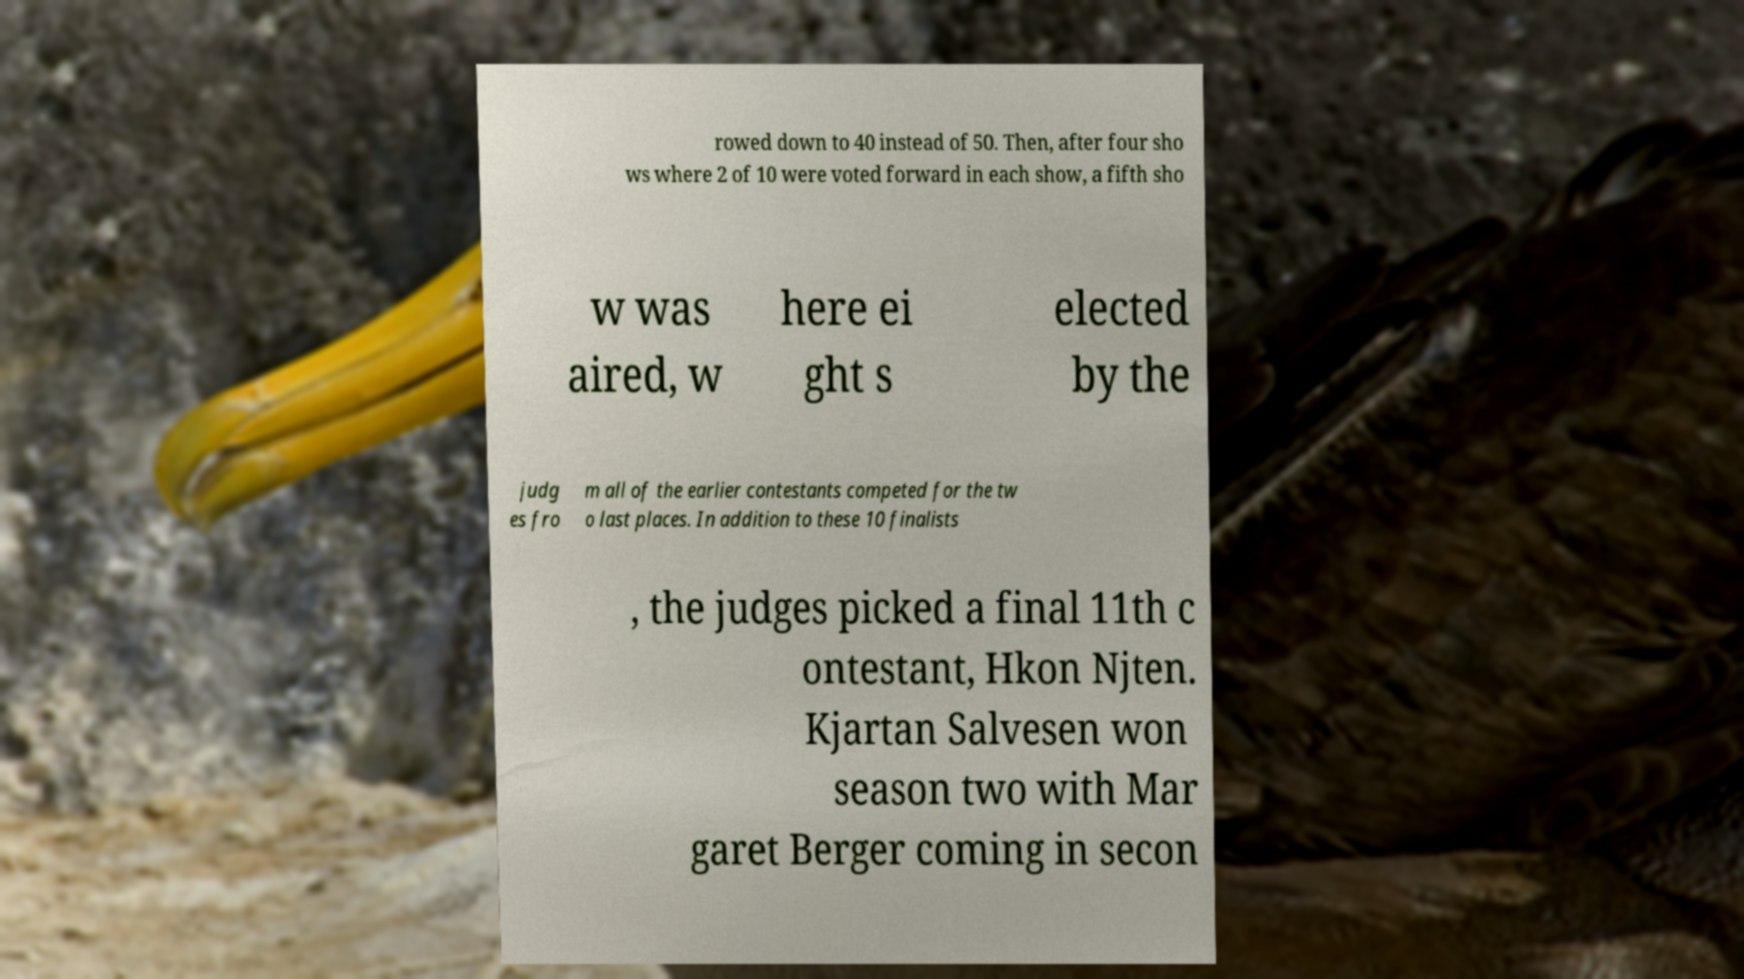What messages or text are displayed in this image? I need them in a readable, typed format. rowed down to 40 instead of 50. Then, after four sho ws where 2 of 10 were voted forward in each show, a fifth sho w was aired, w here ei ght s elected by the judg es fro m all of the earlier contestants competed for the tw o last places. In addition to these 10 finalists , the judges picked a final 11th c ontestant, Hkon Njten. Kjartan Salvesen won season two with Mar garet Berger coming in secon 